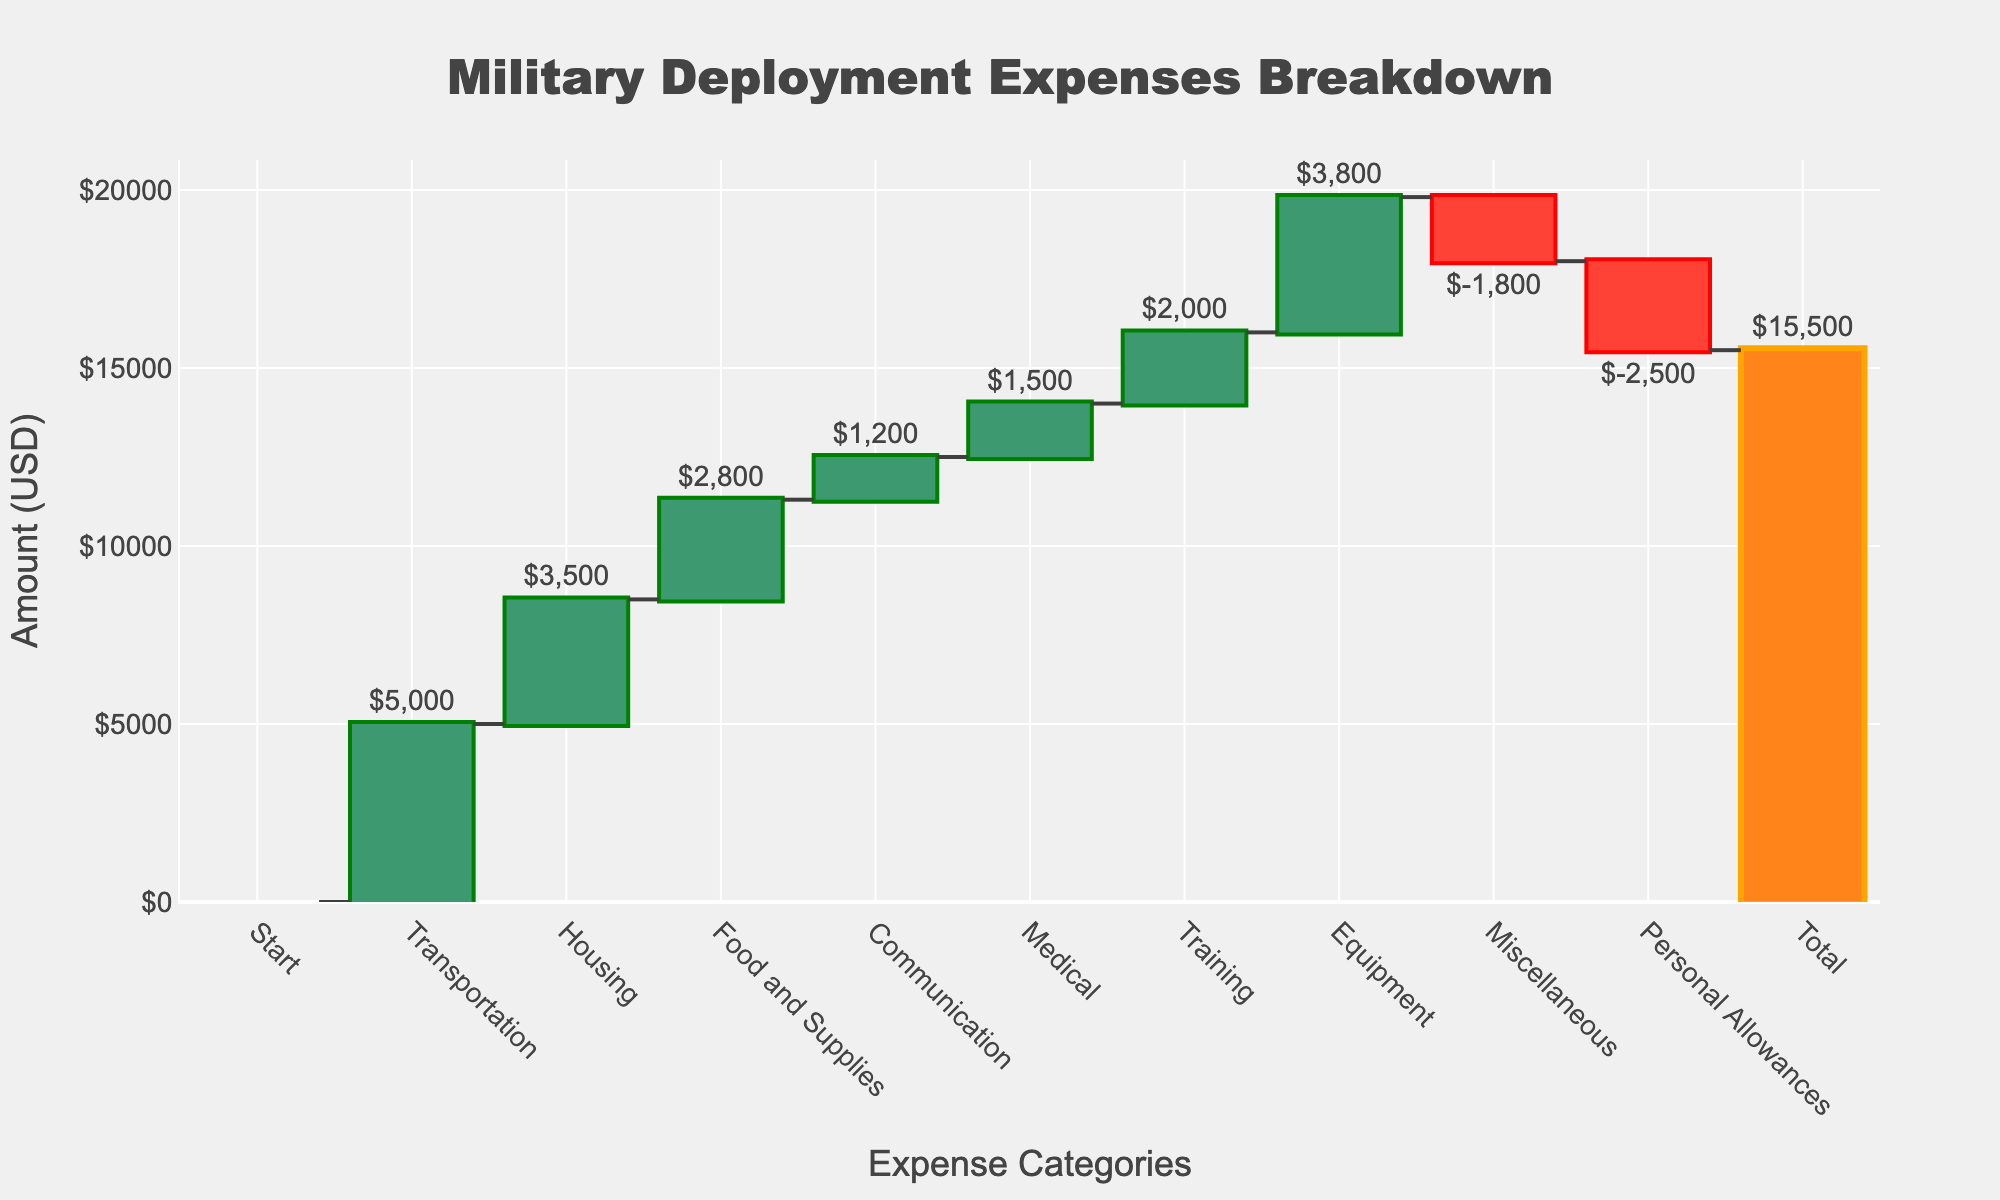What's the total amount of expenses for Military Deployment? Look at the last bar labeled "Total." The amount shown is $15,500.
Answer: $15,500 What is the category with the highest expense? Look for the tallest bar in the positive direction. The "Transportation" category has the tallest bar with $5,000.
Answer: Transportation How much was spent on Medical expenses? Find the bar labeled "Medical." The amount shown is $1,500.
Answer: $1,500 What is the combined expense for Housing and Food and Supplies? Sum the amounts of the "Housing" and "Food and Supplies" categories: 3,500 + 2,800 = 6,300.
Answer: $6,300 Which category had a negative impact on the total expenses, and what was the amount? Identify the bar in the negative direction. "Miscellaneous" had a negative impact of $1,800.
Answer: Miscellaneous, $1,800 How do the expenses of Equipment compare to those of Training? Compare the bar heights for "Equipment" at $3,800 and "Training" at $2,000. "Equipment" expenses are higher.
Answer: Equipment expenses are higher What is the net change in expenses after considering Communication and Personal Allowances? Sum the amount for "Communication" and the negative amount for "Personal Allowances": 1,200 - 2,500 = -1,300.
Answer: -1,300 How much more is spent on Transportation compared to Housing? Subtract the Housing amount from the Transportation amount: 5,000 - 3,500 = 1,500.
Answer: $1,500 What percent of the total expenses is spent on Training? Divide the "Training" amount by the total amount and multiply by 100: (2,000 / 15,500) * 100 ≈ 12.9%.
Answer: 12.9% What is the color used for categories with decreasing expenses? Look for the color indicated for decreasing categories. It is a shade of red.
Answer: Red 